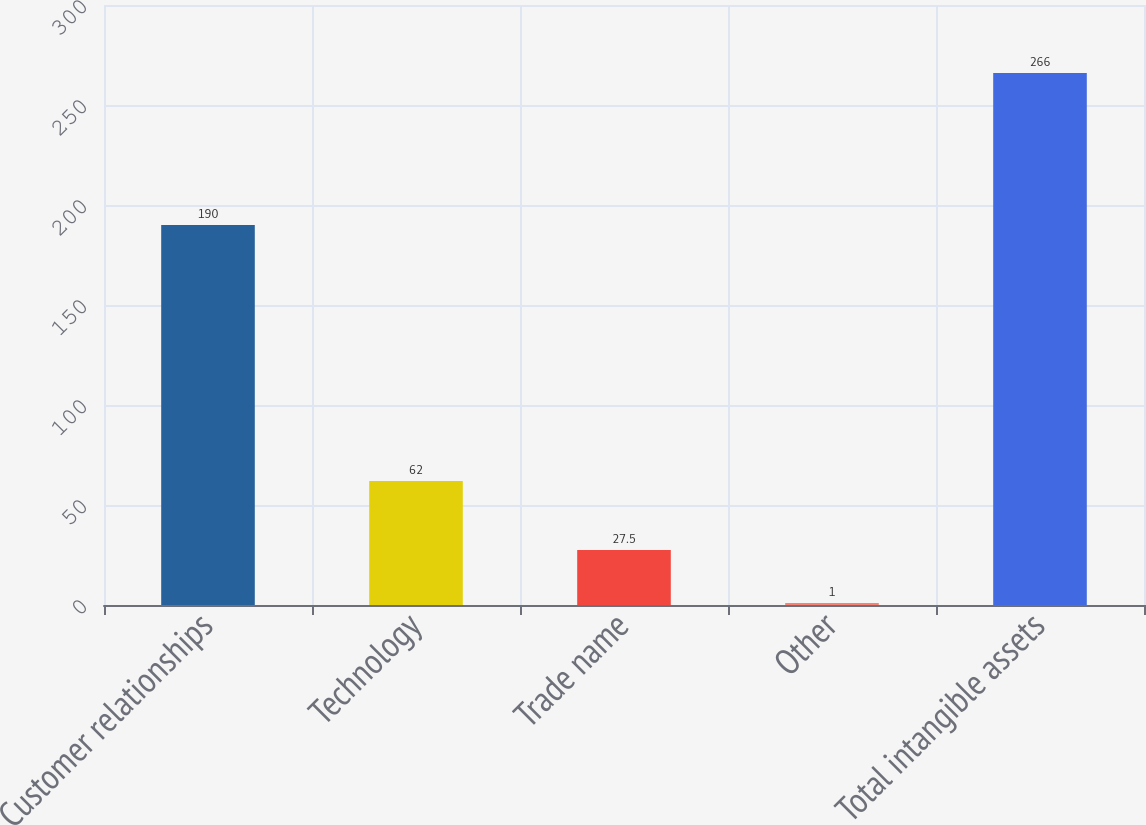Convert chart. <chart><loc_0><loc_0><loc_500><loc_500><bar_chart><fcel>Customer relationships<fcel>Technology<fcel>Trade name<fcel>Other<fcel>Total intangible assets<nl><fcel>190<fcel>62<fcel>27.5<fcel>1<fcel>266<nl></chart> 